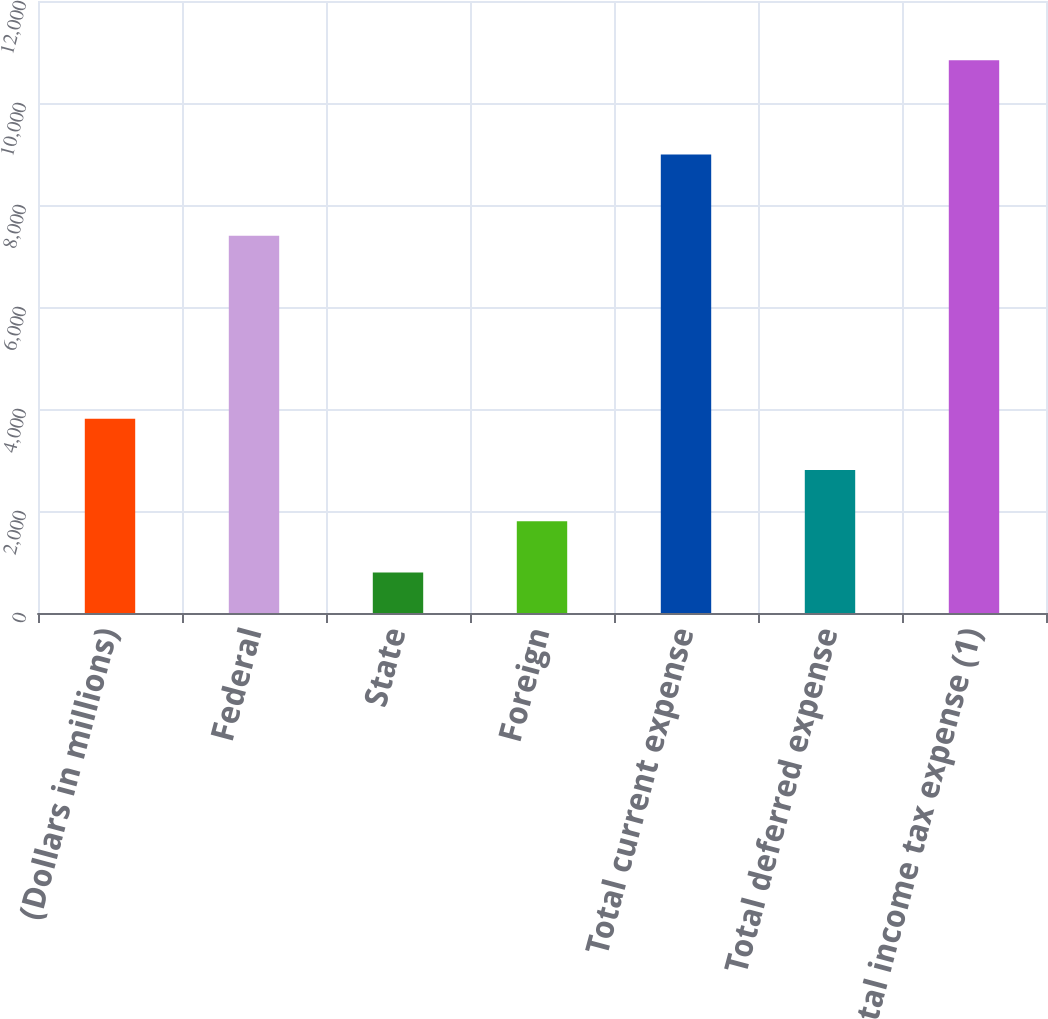<chart> <loc_0><loc_0><loc_500><loc_500><bar_chart><fcel>(Dollars in millions)<fcel>Federal<fcel>State<fcel>Foreign<fcel>Total current expense<fcel>Total deferred expense<fcel>Total income tax expense (1)<nl><fcel>3809.2<fcel>7398<fcel>796<fcel>1800.4<fcel>8990<fcel>2804.8<fcel>10840<nl></chart> 